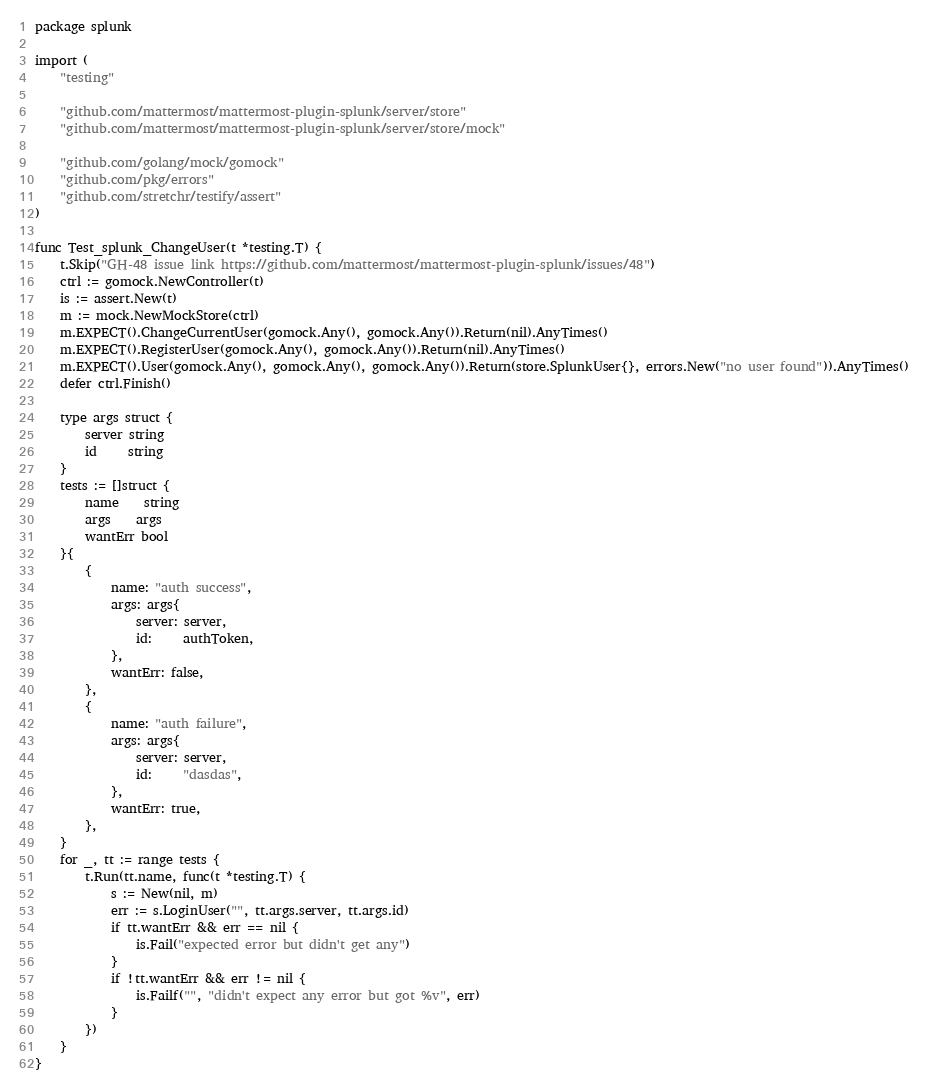Convert code to text. <code><loc_0><loc_0><loc_500><loc_500><_Go_>package splunk

import (
	"testing"

	"github.com/mattermost/mattermost-plugin-splunk/server/store"
	"github.com/mattermost/mattermost-plugin-splunk/server/store/mock"

	"github.com/golang/mock/gomock"
	"github.com/pkg/errors"
	"github.com/stretchr/testify/assert"
)

func Test_splunk_ChangeUser(t *testing.T) {
	t.Skip("GH-48 issue link https://github.com/mattermost/mattermost-plugin-splunk/issues/48")
	ctrl := gomock.NewController(t)
	is := assert.New(t)
	m := mock.NewMockStore(ctrl)
	m.EXPECT().ChangeCurrentUser(gomock.Any(), gomock.Any()).Return(nil).AnyTimes()
	m.EXPECT().RegisterUser(gomock.Any(), gomock.Any()).Return(nil).AnyTimes()
	m.EXPECT().User(gomock.Any(), gomock.Any(), gomock.Any()).Return(store.SplunkUser{}, errors.New("no user found")).AnyTimes()
	defer ctrl.Finish()

	type args struct {
		server string
		id     string
	}
	tests := []struct {
		name    string
		args    args
		wantErr bool
	}{
		{
			name: "auth success",
			args: args{
				server: server,
				id:     authToken,
			},
			wantErr: false,
		},
		{
			name: "auth failure",
			args: args{
				server: server,
				id:     "dasdas",
			},
			wantErr: true,
		},
	}
	for _, tt := range tests {
		t.Run(tt.name, func(t *testing.T) {
			s := New(nil, m)
			err := s.LoginUser("", tt.args.server, tt.args.id)
			if tt.wantErr && err == nil {
				is.Fail("expected error but didn't get any")
			}
			if !tt.wantErr && err != nil {
				is.Failf("", "didn't expect any error but got %v", err)
			}
		})
	}
}
</code> 